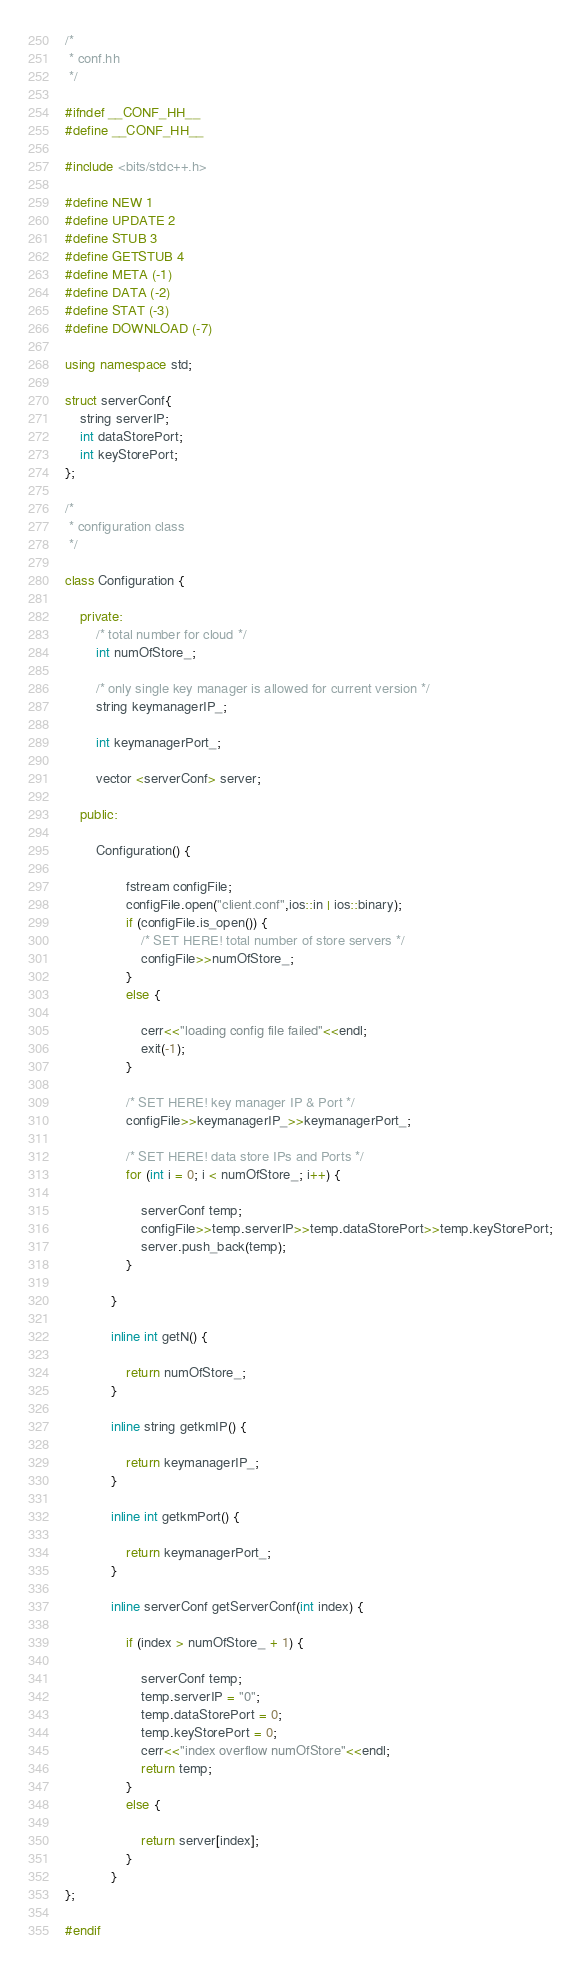<code> <loc_0><loc_0><loc_500><loc_500><_C++_>/*
 * conf.hh
 */

#ifndef __CONF_HH__
#define __CONF_HH__

#include <bits/stdc++.h>

#define NEW 1
#define UPDATE 2
#define STUB 3
#define GETSTUB 4
#define META (-1)
#define DATA (-2)
#define STAT (-3)
#define DOWNLOAD (-7)

using namespace std;

struct serverConf{
	string serverIP;
	int dataStorePort;
	int keyStorePort;
};

/*
 * configuration class
 */

class Configuration {

	private:
		/* total number for cloud */
		int numOfStore_;

		/* only single key manager is allowed for current version */
		string keymanagerIP_;

		int keymanagerPort_;

		vector <serverConf> server;

	public:

		Configuration() {
			
				fstream configFile;
				configFile.open("client.conf",ios::in | ios::binary);
				if (configFile.is_open()) {
					/* SET HERE! total number of store servers */
					configFile>>numOfStore_;
				}
				else {
			
					cerr<<"loading config file failed"<<endl;
					exit(-1);
				}
			
				/* SET HERE! key manager IP & Port */
				configFile>>keymanagerIP_>>keymanagerPort_;
			
				/* SET HERE! data store IPs and Ports */
				for (int i = 0; i < numOfStore_; i++) {
					
					serverConf temp;
					configFile>>temp.serverIP>>temp.dataStorePort>>temp.keyStorePort;
					server.push_back(temp); 
				}
			
			}
			
			inline int getN() { 
			
				return numOfStore_; 
			}
			
			inline string getkmIP() { 
			
				return keymanagerIP_; 
			}
			
			inline int getkmPort() { 
						
				return keymanagerPort_; 
			}
			
			inline serverConf getServerConf(int index) {
			
				if (index > numOfStore_ + 1) {
					
					serverConf temp;
					temp.serverIP = "0";
					temp.dataStorePort = 0;
					temp.keyStorePort = 0;
					cerr<<"index overflow numOfStore"<<endl;
					return temp;
				}
				else {
					
					return server[index];
				}
			}
};

#endif
</code> 